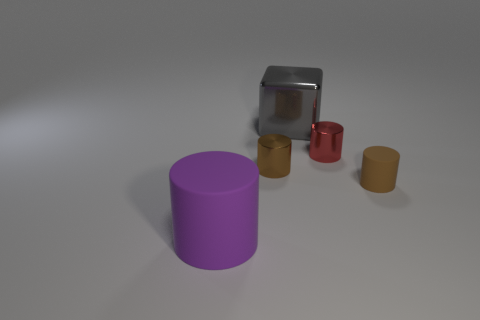Can you infer the purpose of this setup? Is this a product display or something else? The image seems to have been designed to showcase a variety of geometric shapes and textures, perhaps for an artistic display or for a visual assessment where differences in size, color, and material are being evaluated. It's less likely a product display due to the uniformity and non-functional nature of the objects, which suggests an educational or illustrative purpose instead. 